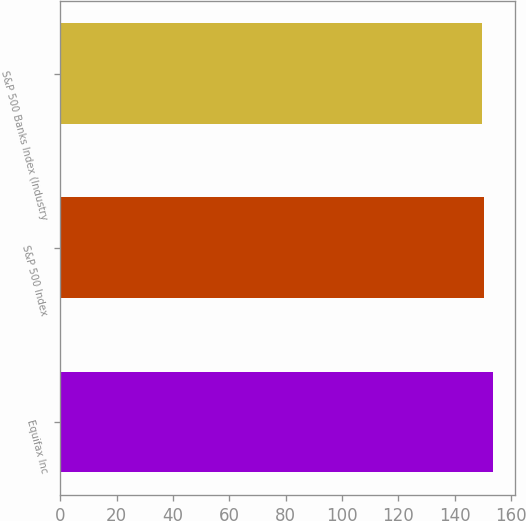<chart> <loc_0><loc_0><loc_500><loc_500><bar_chart><fcel>Equifax Inc<fcel>S&P 500 Index<fcel>S&P 500 Banks Index (Industry<nl><fcel>153.68<fcel>150.51<fcel>149.79<nl></chart> 